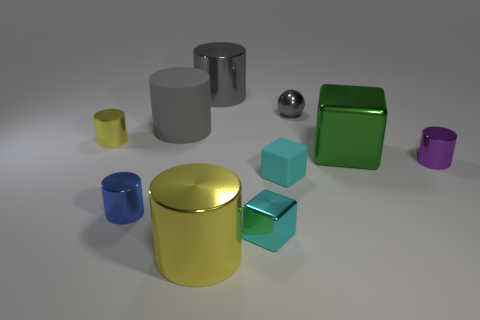Subtract all small blue metallic cylinders. How many cylinders are left? 5 Subtract all cyan cylinders. How many cyan blocks are left? 2 Subtract all purple cylinders. How many cylinders are left? 5 Subtract all cylinders. How many objects are left? 4 Subtract 1 spheres. How many spheres are left? 0 Subtract all yellow cubes. Subtract all cyan spheres. How many cubes are left? 3 Subtract all small metal blocks. Subtract all large gray things. How many objects are left? 7 Add 8 tiny yellow metal cylinders. How many tiny yellow metal cylinders are left? 9 Add 4 cyan metal cubes. How many cyan metal cubes exist? 5 Subtract 0 purple spheres. How many objects are left? 10 